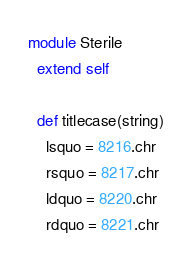Convert code to text. <code><loc_0><loc_0><loc_500><loc_500><_Crystal_>module Sterile
  extend self

  def titlecase(string)
    lsquo = 8216.chr
    rsquo = 8217.chr
    ldquo = 8220.chr
    rdquo = 8221.chr</code> 